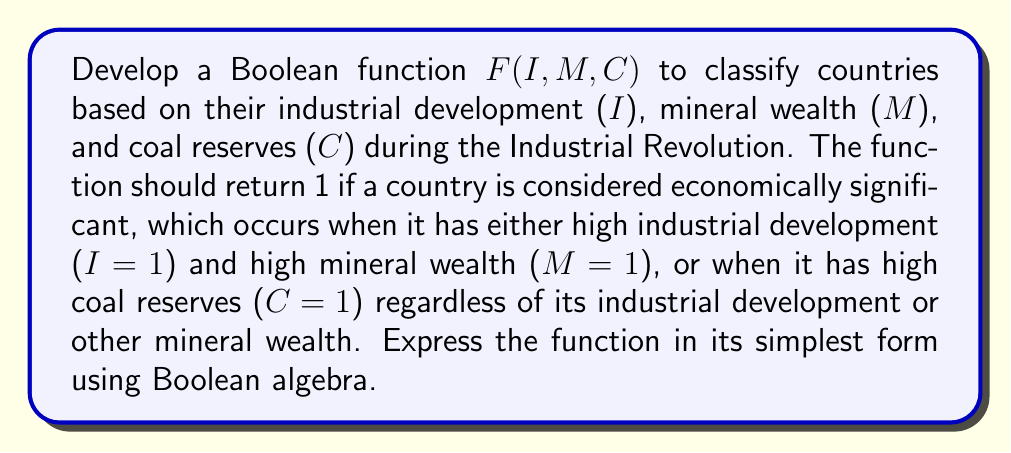Provide a solution to this math problem. Let's approach this step-by-step:

1) First, we need to identify the conditions for a country to be considered economically significant:
   - High industrial development AND high mineral wealth
   OR
   - High coal reserves (regardless of other factors)

2) We can express this in Boolean algebra as:
   $F(I, M, C) = (I \cdot M) + C$

3) This expression is already in its simplest form, but let's verify using Boolean algebra laws:

   a) We can't apply the distributive law as there's no common term.
   b) We can't apply absorption law as C is not multiplied by any term.
   c) The terms (I · M) and C are already in their simplest forms.

4) Therefore, $F(I, M, C) = (I \cdot M) + C$ is the simplest form of our Boolean function.

5) This function accurately represents our classification criteria:
   - If I=1 and M=1, the function will return 1 regardless of C.
   - If C=1, the function will return 1 regardless of I and M.
   - In all other cases, the function will return 0.

This Boolean function aligns with the historical context of the Industrial Revolution, where countries with developed industries and rich mineral resources, or abundant coal reserves, played significant roles in the global economy.
Answer: $F(I, M, C) = (I \cdot M) + C$ 